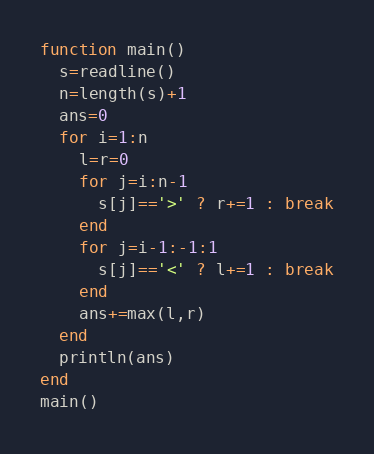Convert code to text. <code><loc_0><loc_0><loc_500><loc_500><_Julia_>function main()
  s=readline()
  n=length(s)+1
  ans=0
  for i=1:n
    l=r=0
    for j=i:n-1
      s[j]=='>' ? r+=1 : break
    end
    for j=i-1:-1:1
      s[j]=='<' ? l+=1 : break
    end
    ans+=max(l,r)
  end
  println(ans)
end
main()</code> 